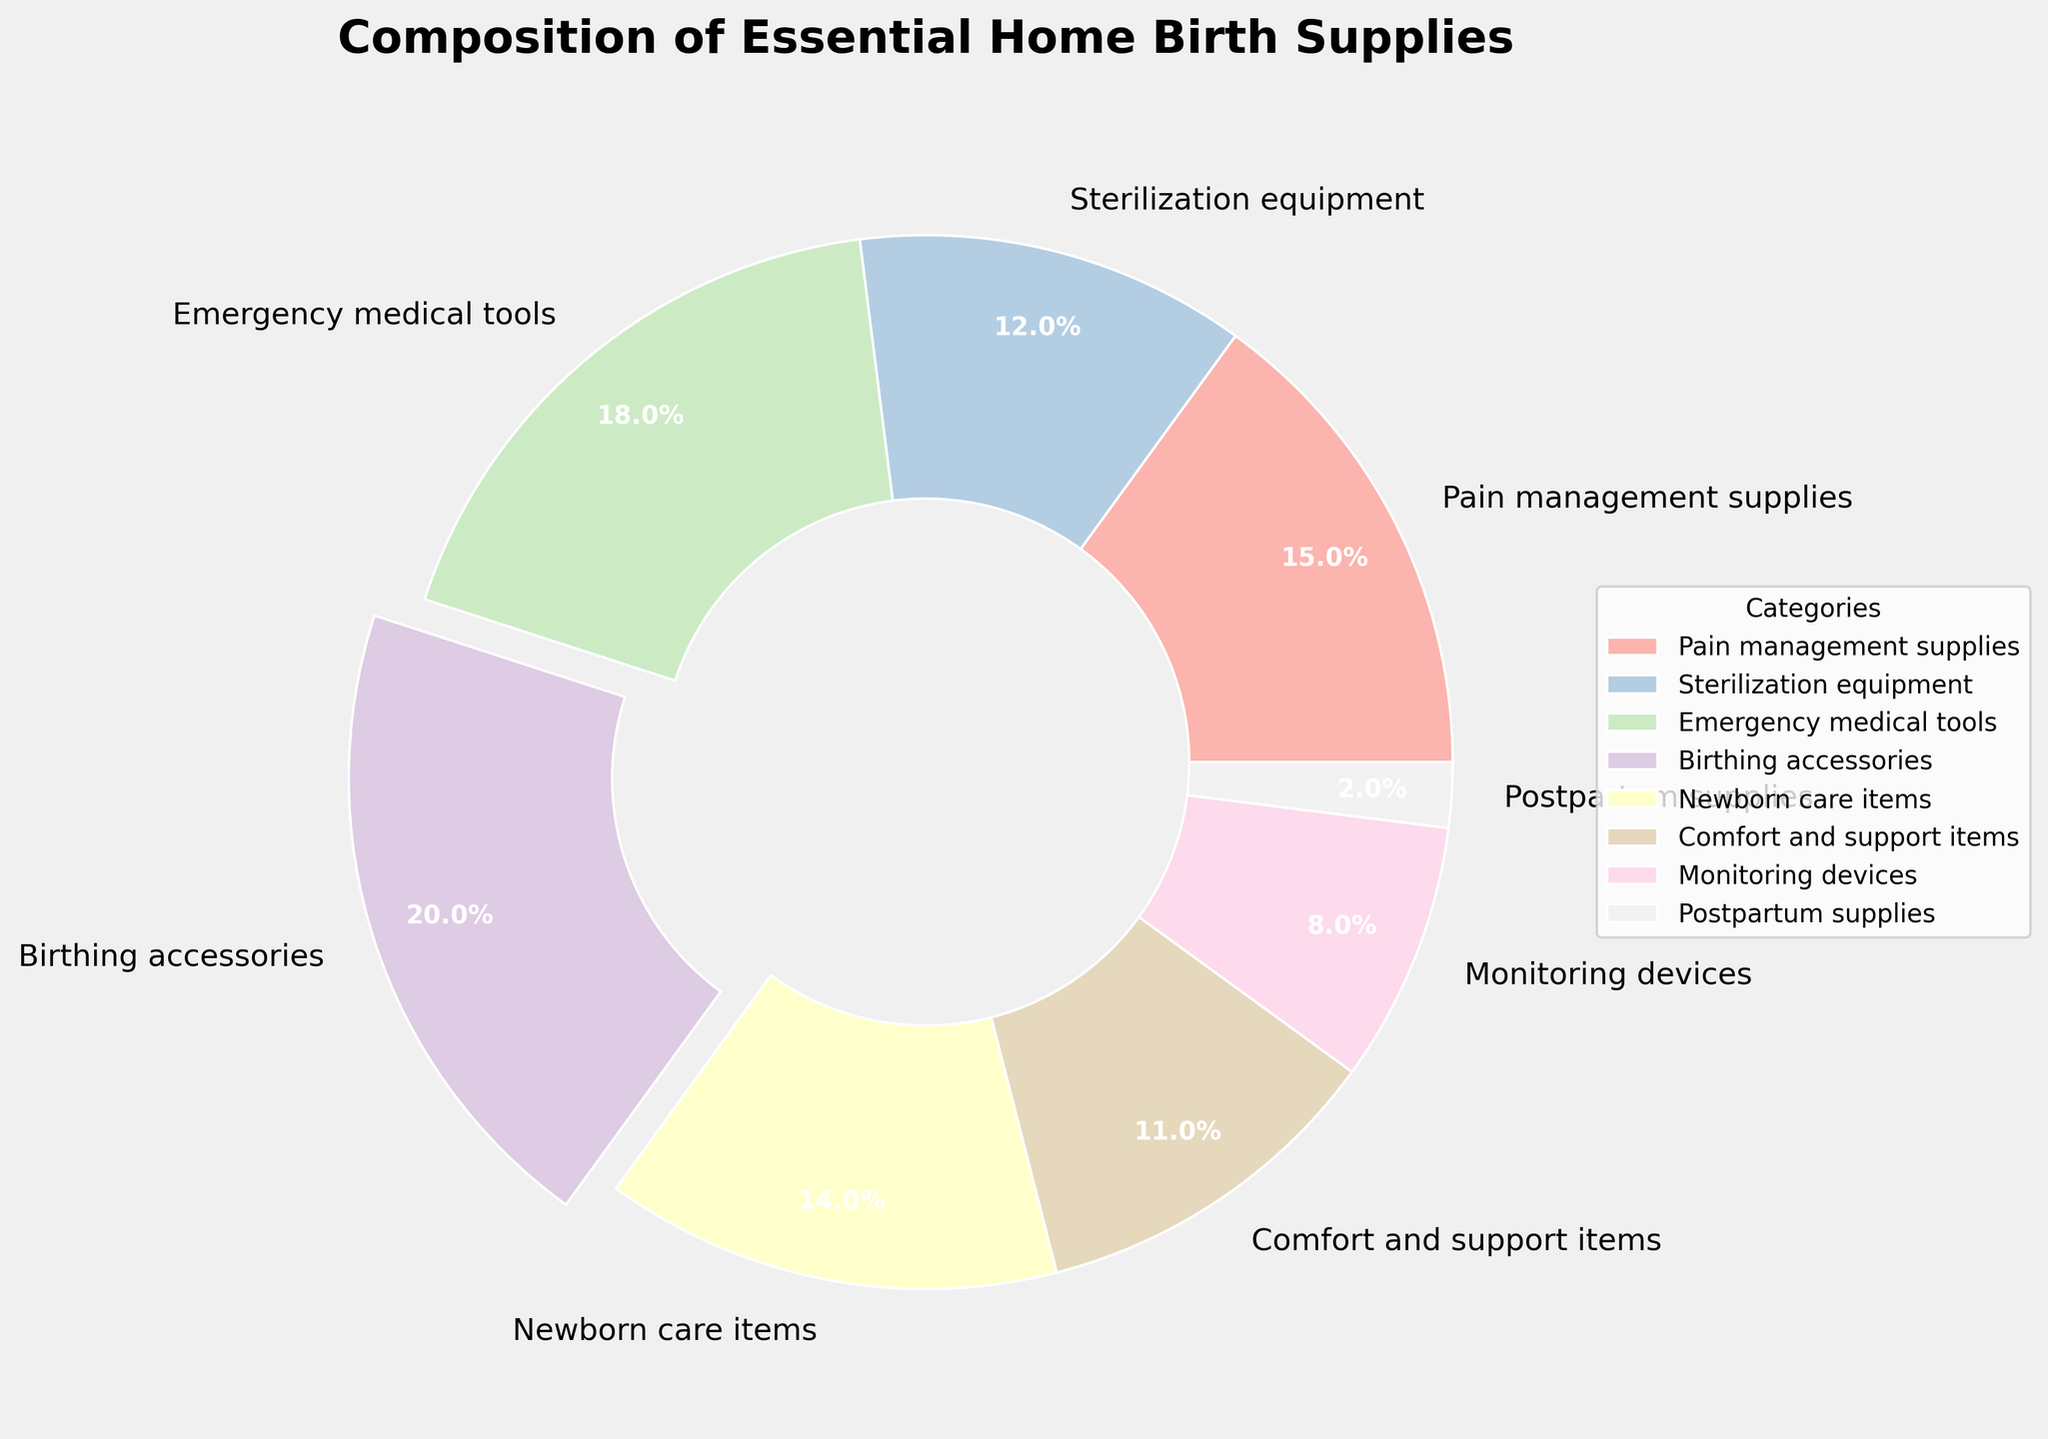Which category has the highest percentage in the pie chart? The category with the highest percentage is the one where the slice is largest and it is slightly separated from the rest (exploded). According to the chart, Birthing accessories have the highest percentage at 20%.
Answer: Birthing accessories Which category makes up the smallest portion of the supplies? The category with the smallest portion can be identified by its relatively smallest slice. In the chart, Postpartum supplies have the smallest portion at 2%.
Answer: Postpartum supplies What's the combined percentage of Pain management supplies and Newborn care items? To find the combined percentage, add the percentages of Pain management supplies (15%) and Newborn care items (14%). Hence, 15 + 14 = 29%.
Answer: 29% How does the percentage of Sterilization equipment compare to Monitoring devices? To compare, locate the slices for both categories and note their percentages. Sterilization equipment is at 12%, while Monitoring devices are at 8%. So, Sterilization equipment has a higher percentage than Monitoring devices.
Answer: Sterilization equipment has a higher percentage What is the difference in percentage between Emergency medical tools and Comfort and support items? Subtract the percentage of Comfort and support items (11%) from that of Emergency medical tools (18%). So, 18 - 11 = 7%.
Answer: 7% Combine the percentages of the three smallest categories. What is the total? Identify the smallest categories: Postpartum supplies (2%), Monitoring devices (8%), and Comfort and support items (11%). Add these values together: 2 + 8 + 11 = 21%.
Answer: 21% Which categories have a percentage above 15%? Look for slices where the percentage label is above 15%. The categories above 15% are Emergency medical tools (18%) and Birthing accessories (20%).
Answer: Emergency medical tools and Birthing accessories Identify the category with the pale green color. What percentage does it represent? Observing the chart, the pie slice with the pale green color corresponds to Sterilization equipment, with a percentage of 12%.
Answer: Sterilization equipment, 12% Are there more categories with a percentage below 10% or above 10%? Count the categories below and above 10%. Categories below 10%: Monitoring devices (8%) and Postpartum supplies (2%) = 2 categories. Categories above 10%: Pain management supplies (15%), Sterilization equipment (12%), Emergency medical tools (18%), Birthing accessories (20%), Newborn care items (14%), Comfort and support items (11%) = 6 categories. Thus, there are more categories above 10%.
Answer: More categories above 10% 